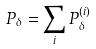<formula> <loc_0><loc_0><loc_500><loc_500>P _ { \delta } = \sum _ { i } P _ { \delta } ^ { ( i ) }</formula> 